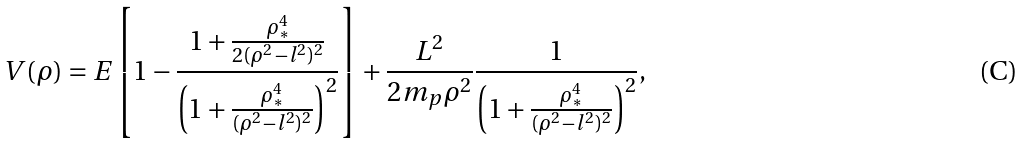Convert formula to latex. <formula><loc_0><loc_0><loc_500><loc_500>V ( \rho ) = E \left [ 1 - \frac { 1 + \frac { \rho _ { * } ^ { 4 } } { 2 ( \rho ^ { 2 } - l ^ { 2 } ) ^ { 2 } } } { \left ( 1 + \frac { \rho _ { * } ^ { 4 } } { ( \rho ^ { 2 } - l ^ { 2 } ) ^ { 2 } } \right ) ^ { 2 } } \right ] + \frac { L ^ { 2 } } { 2 m _ { p } \rho ^ { 2 } } \frac { 1 } { \left ( 1 + \frac { \rho _ { * } ^ { 4 } } { ( \rho ^ { 2 } - l ^ { 2 } ) ^ { 2 } } \right ) ^ { 2 } } ,</formula> 